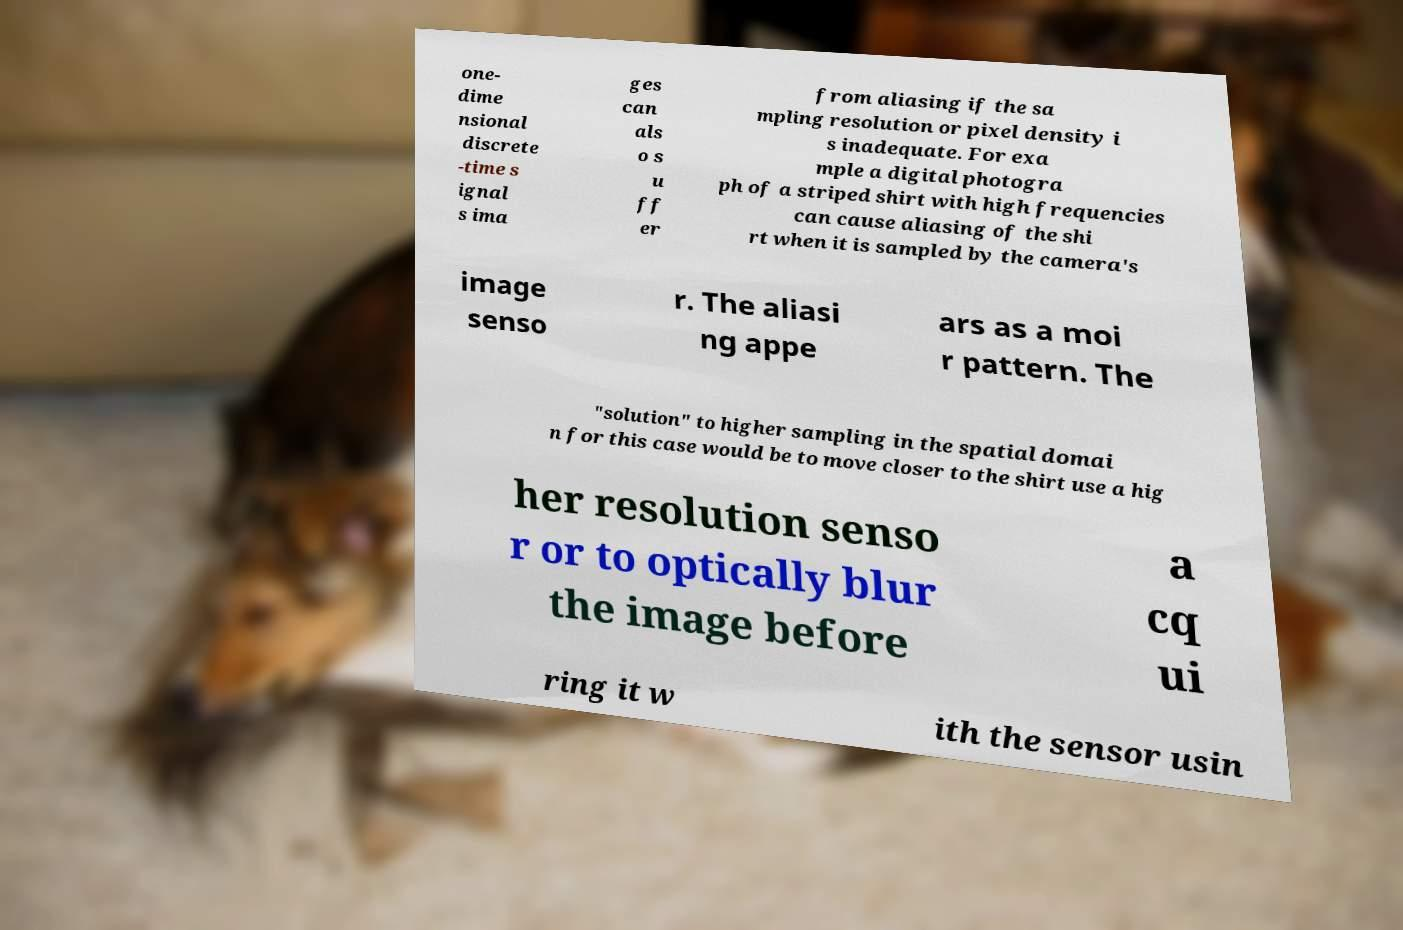Can you accurately transcribe the text from the provided image for me? one- dime nsional discrete -time s ignal s ima ges can als o s u ff er from aliasing if the sa mpling resolution or pixel density i s inadequate. For exa mple a digital photogra ph of a striped shirt with high frequencies can cause aliasing of the shi rt when it is sampled by the camera's image senso r. The aliasi ng appe ars as a moi r pattern. The "solution" to higher sampling in the spatial domai n for this case would be to move closer to the shirt use a hig her resolution senso r or to optically blur the image before a cq ui ring it w ith the sensor usin 